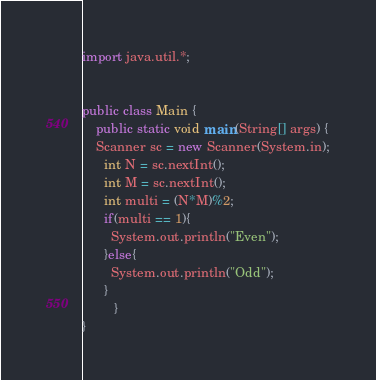<code> <loc_0><loc_0><loc_500><loc_500><_Java_>import java.util.*;
 
 
public class Main {
    public static void main(String[] args) {
    Scanner sc = new Scanner(System.in);
      int N = sc.nextInt();
      int M = sc.nextInt();
      int multi = (N*M)%2;
      if(multi == 1){
        System.out.println("Even");
      }else{
        System.out.println("Odd");
      }
         }
}</code> 